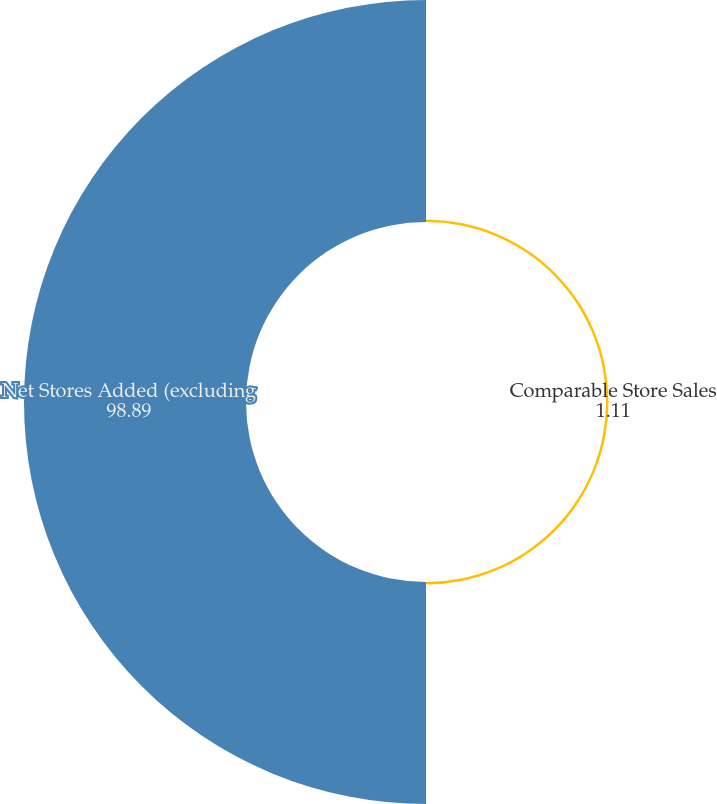<chart> <loc_0><loc_0><loc_500><loc_500><pie_chart><fcel>Comparable Store Sales<fcel>Net Stores Added (excluding<nl><fcel>1.11%<fcel>98.89%<nl></chart> 